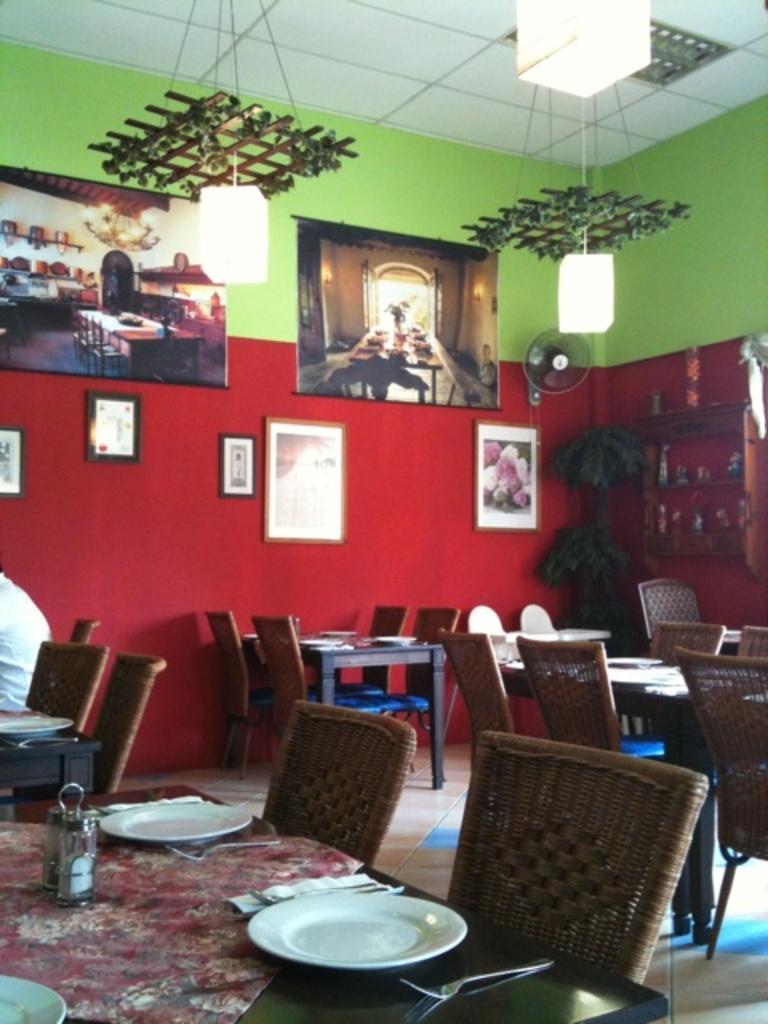Could you give a brief overview of what you see in this image? In this image, there is an inside view of a restaurant. There are some chairs and tables. There is a table at the bottom of this picture contains plates, spoons and bottles. There are three lights at the top. There are some photo frames at the top of this picture. 